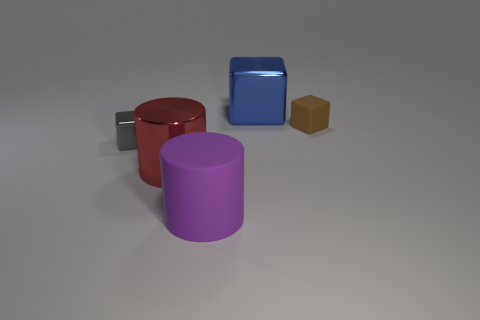Is the number of gray shiny objects to the left of the brown rubber cube greater than the number of large blue objects behind the gray metal cube?
Your answer should be compact. No. There is a metallic cylinder that is the same size as the blue metallic cube; what is its color?
Make the answer very short. Red. There is a tiny object that is on the left side of the big block; what is it made of?
Offer a very short reply. Metal. There is a large block that is the same material as the large red cylinder; what is its color?
Your answer should be very brief. Blue. What number of cylinders have the same size as the purple thing?
Provide a succinct answer. 1. There is a matte thing that is behind the purple thing; does it have the same size as the tiny shiny block?
Keep it short and to the point. Yes. The big object that is behind the big matte thing and right of the metal cylinder has what shape?
Provide a short and direct response. Cube. Are there any large red cylinders in front of the big blue metal thing?
Give a very brief answer. Yes. Do the purple thing and the small gray thing have the same shape?
Keep it short and to the point. No. Are there an equal number of large rubber cylinders that are to the left of the large rubber thing and gray cubes right of the small brown block?
Provide a short and direct response. Yes. 